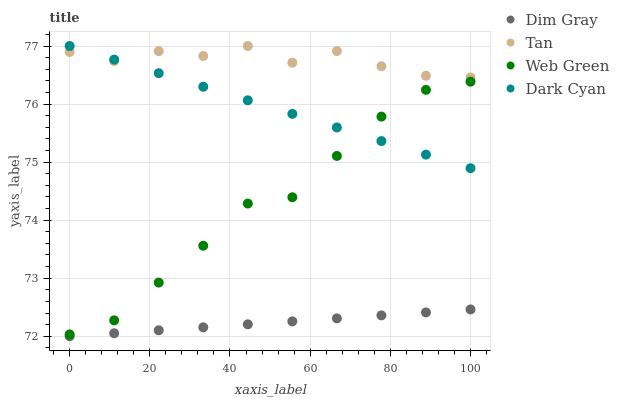Does Dim Gray have the minimum area under the curve?
Answer yes or no. Yes. Does Tan have the maximum area under the curve?
Answer yes or no. Yes. Does Tan have the minimum area under the curve?
Answer yes or no. No. Does Dim Gray have the maximum area under the curve?
Answer yes or no. No. Is Dark Cyan the smoothest?
Answer yes or no. Yes. Is Tan the roughest?
Answer yes or no. Yes. Is Dim Gray the smoothest?
Answer yes or no. No. Is Dim Gray the roughest?
Answer yes or no. No. Does Dim Gray have the lowest value?
Answer yes or no. Yes. Does Tan have the lowest value?
Answer yes or no. No. Does Tan have the highest value?
Answer yes or no. Yes. Does Dim Gray have the highest value?
Answer yes or no. No. Is Dim Gray less than Dark Cyan?
Answer yes or no. Yes. Is Dark Cyan greater than Dim Gray?
Answer yes or no. Yes. Does Tan intersect Dark Cyan?
Answer yes or no. Yes. Is Tan less than Dark Cyan?
Answer yes or no. No. Is Tan greater than Dark Cyan?
Answer yes or no. No. Does Dim Gray intersect Dark Cyan?
Answer yes or no. No. 